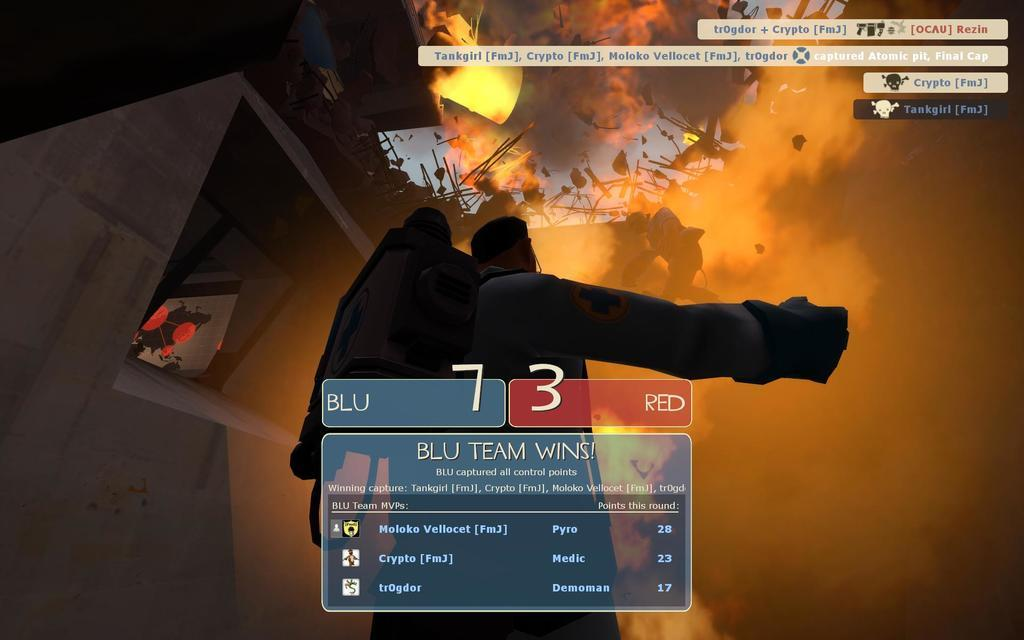<image>
Relay a brief, clear account of the picture shown. A game screen reading "BLU TEAM WINS" with scores of 7 for BLU team and 3 for RED team. 